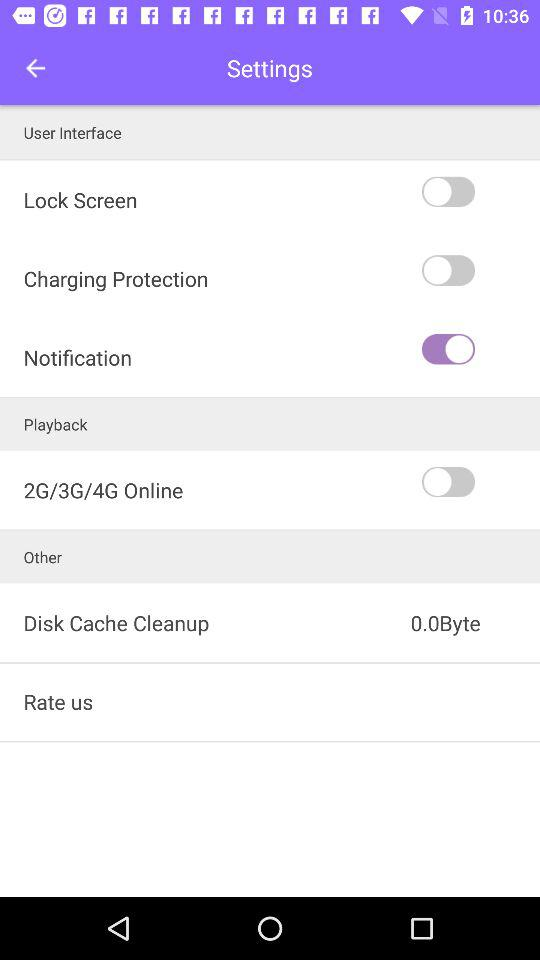What's the "Disk Cache Cleanup" unit size? The size is 0.0Byte. 